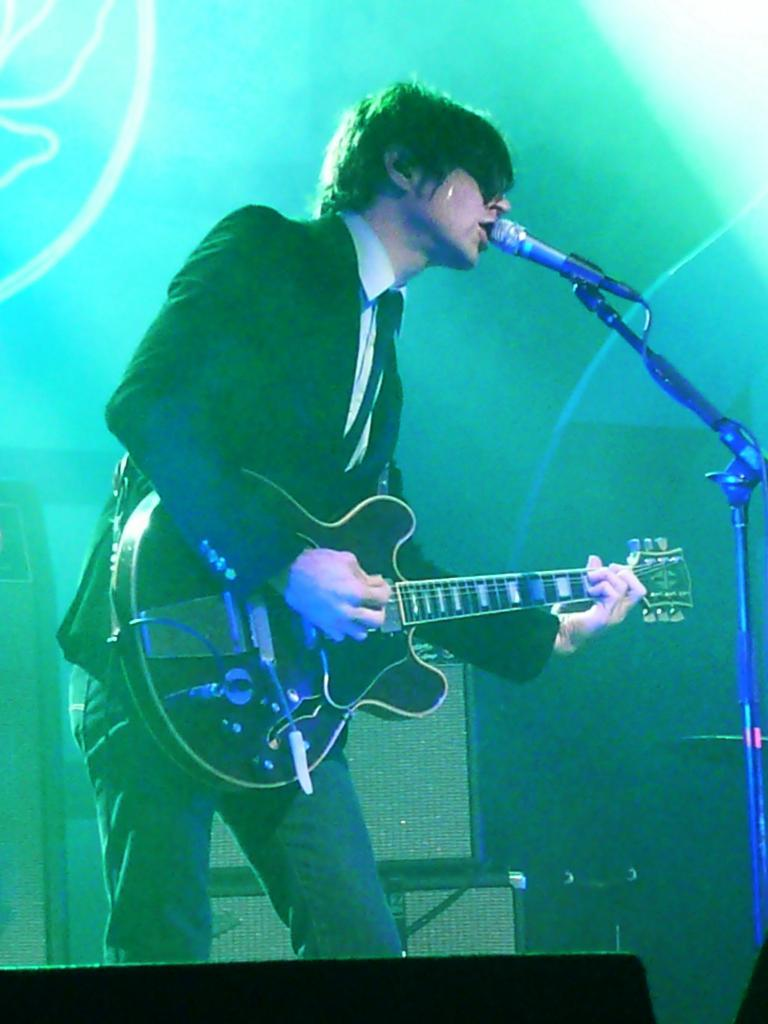What is the main subject of the image? There is a person in the image. What is the person doing in the image? The person is standing in front of a mic. What object is the person holding in the image? The person is holding a guitar. What type of oatmeal is being served in the image? There is no oatmeal present in the image. What is the texture of the guitar in the image? The texture of the guitar cannot be determined from the image alone, as it is a two-dimensional representation. 